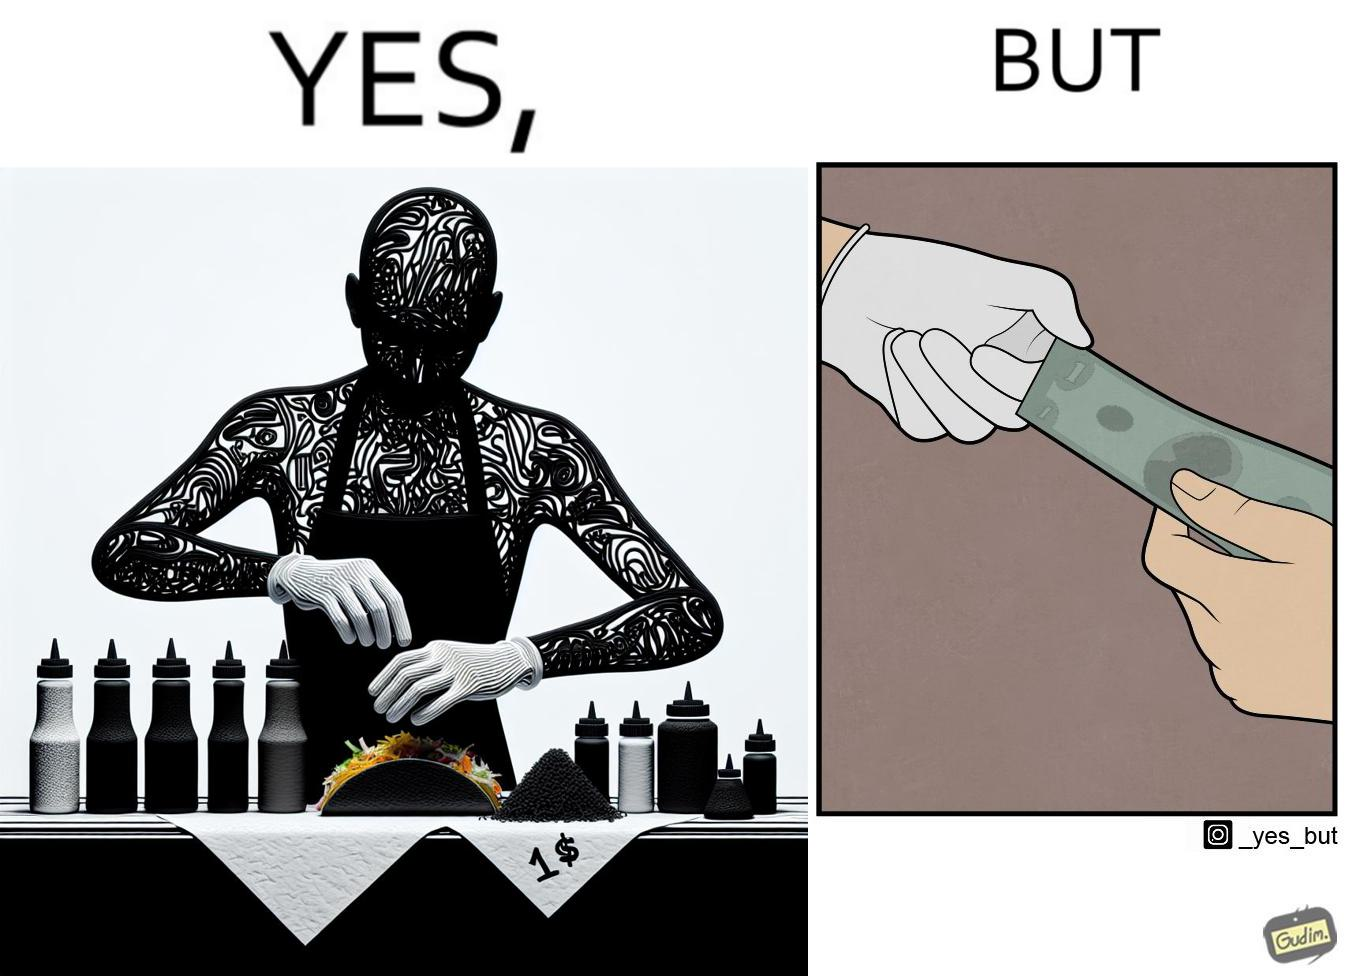Is there satirical content in this image? Yes, this image is satirical. 